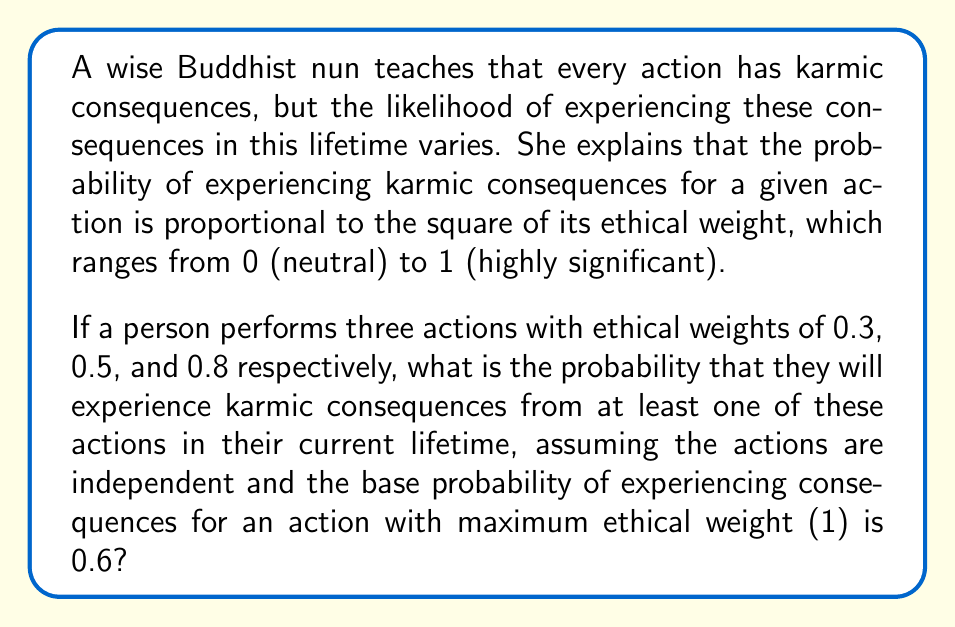Show me your answer to this math problem. Let's approach this step-by-step:

1) First, we need to calculate the probability of experiencing karmic consequences for each action:

   For an action with ethical weight $x$, the probability is $0.6x^2$

   Action 1: $P(A_1) = 0.6 * 0.3^2 = 0.054$
   Action 2: $P(A_2) = 0.6 * 0.5^2 = 0.15$
   Action 3: $P(A_3) = 0.6 * 0.8^2 = 0.384$

2) Now, we need to find the probability of experiencing consequences from at least one action. It's easier to calculate the probability of not experiencing consequences from any action and then subtract this from 1.

3) The probability of not experiencing consequences from an action is the complement of experiencing consequences:

   $P(\text{not } A_1) = 1 - 0.054 = 0.946$
   $P(\text{not } A_2) = 1 - 0.15 = 0.85$
   $P(\text{not } A_3) = 1 - 0.384 = 0.616$

4) Since the actions are independent, the probability of not experiencing consequences from any of the actions is the product of the individual probabilities:

   $P(\text{none}) = 0.946 * 0.85 * 0.616 = 0.4956$

5) Therefore, the probability of experiencing consequences from at least one action is:

   $P(\text{at least one}) = 1 - P(\text{none}) = 1 - 0.4956 = 0.5044$
Answer: The probability of experiencing karmic consequences from at least one of these actions in the current lifetime is approximately 0.5044 or 50.44%. 